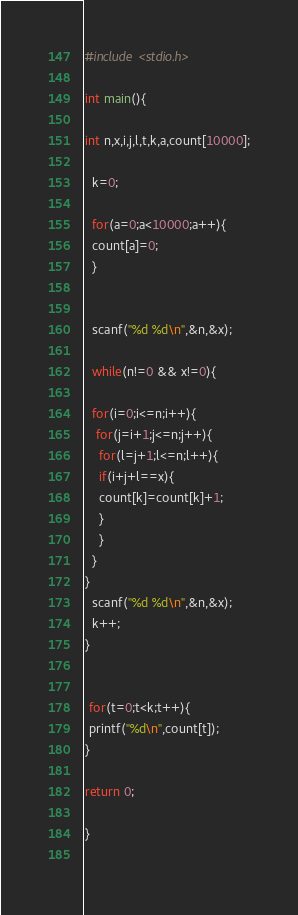<code> <loc_0><loc_0><loc_500><loc_500><_C_>#include <stdio.h>

int main(){

int n,x,i,j,l,t,k,a,count[10000];

  k=0;

  for(a=0;a<10000;a++){
  count[a]=0;
  }
  
  
  scanf("%d %d\n",&n,&x);

  while(n!=0 && x!=0){

  for(i=0;i<=n;i++){   
   for(j=i+1;j<=n;j++){
    for(l=j+1;l<=n;l++){
    if(i+j+l==x){  
    count[k]=count[k]+1;
    }
    }
  } 
}
  scanf("%d %d\n",&n,&x);
  k++;
}


 for(t=0;t<k;t++){
 printf("%d\n",count[t]);
}

return 0;

}
   
</code> 